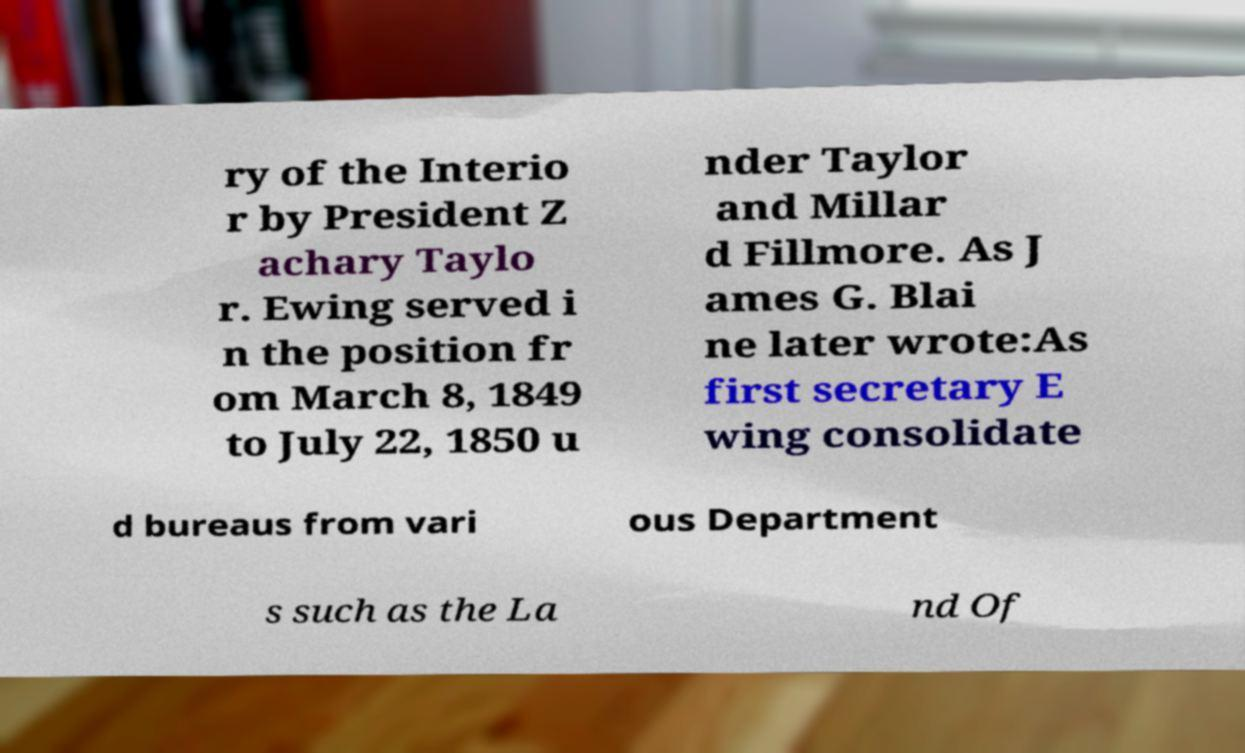Can you read and provide the text displayed in the image?This photo seems to have some interesting text. Can you extract and type it out for me? ry of the Interio r by President Z achary Taylo r. Ewing served i n the position fr om March 8, 1849 to July 22, 1850 u nder Taylor and Millar d Fillmore. As J ames G. Blai ne later wrote:As first secretary E wing consolidate d bureaus from vari ous Department s such as the La nd Of 